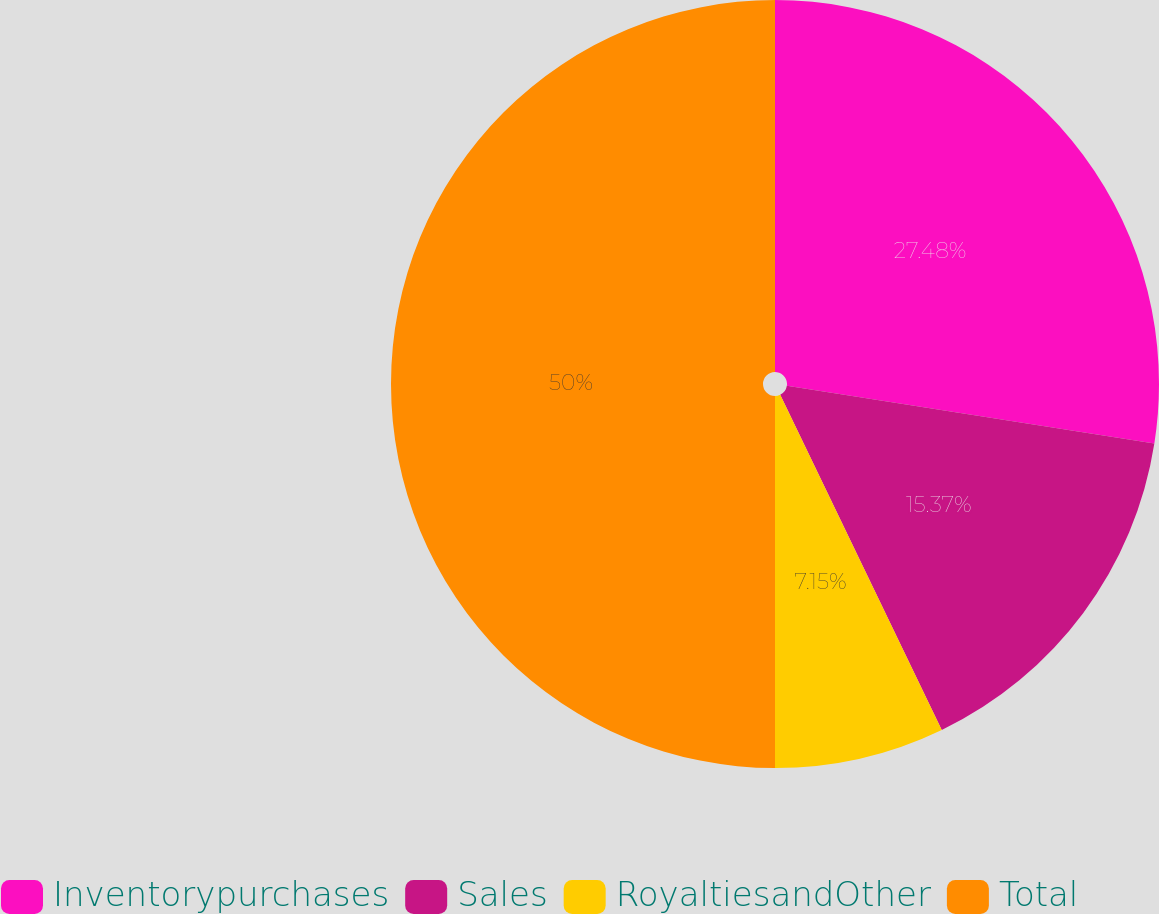<chart> <loc_0><loc_0><loc_500><loc_500><pie_chart><fcel>Inventorypurchases<fcel>Sales<fcel>RoyaltiesandOther<fcel>Total<nl><fcel>27.48%<fcel>15.37%<fcel>7.15%<fcel>50.0%<nl></chart> 